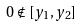<formula> <loc_0><loc_0><loc_500><loc_500>0 \notin [ y _ { 1 } , y _ { 2 } ]</formula> 